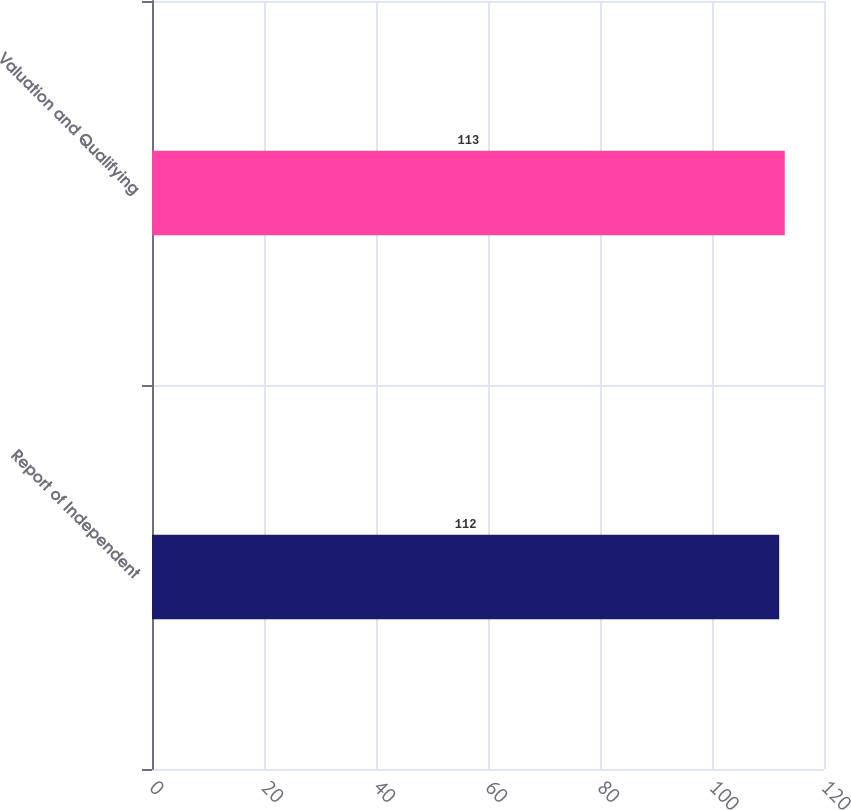Convert chart. <chart><loc_0><loc_0><loc_500><loc_500><bar_chart><fcel>Report of Independent<fcel>Valuation and Qualifying<nl><fcel>112<fcel>113<nl></chart> 